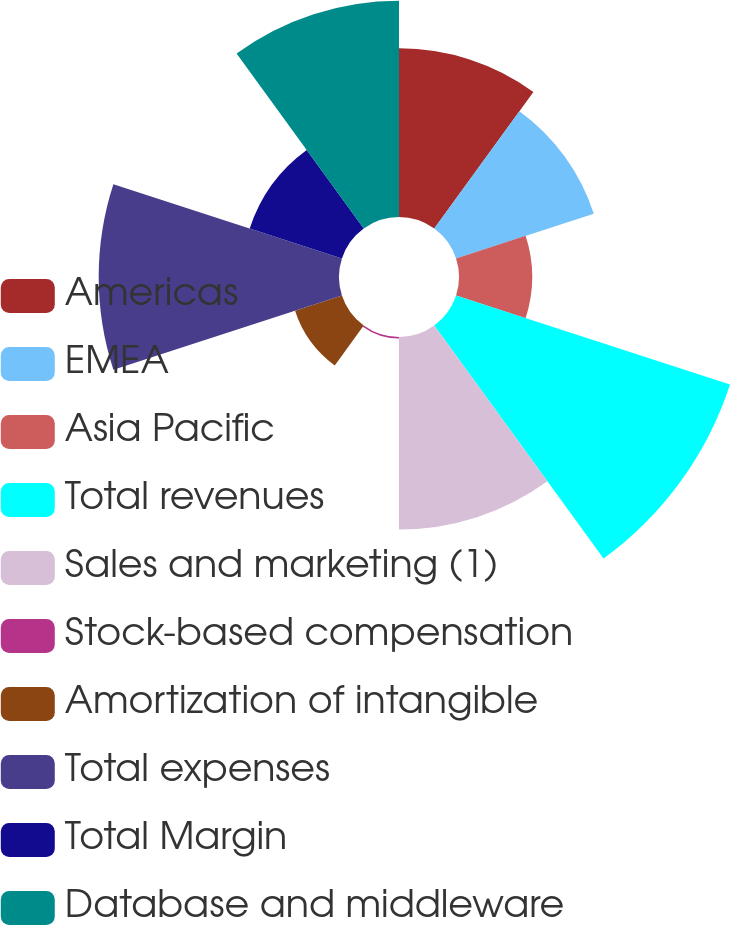Convert chart. <chart><loc_0><loc_0><loc_500><loc_500><pie_chart><fcel>Americas<fcel>EMEA<fcel>Asia Pacific<fcel>Total revenues<fcel>Sales and marketing (1)<fcel>Stock-based compensation<fcel>Amortization of intangible<fcel>Total expenses<fcel>Total Margin<fcel>Database and middleware<nl><fcel>11.46%<fcel>9.84%<fcel>4.97%<fcel>19.57%<fcel>13.08%<fcel>0.11%<fcel>3.35%<fcel>16.33%<fcel>6.59%<fcel>14.7%<nl></chart> 